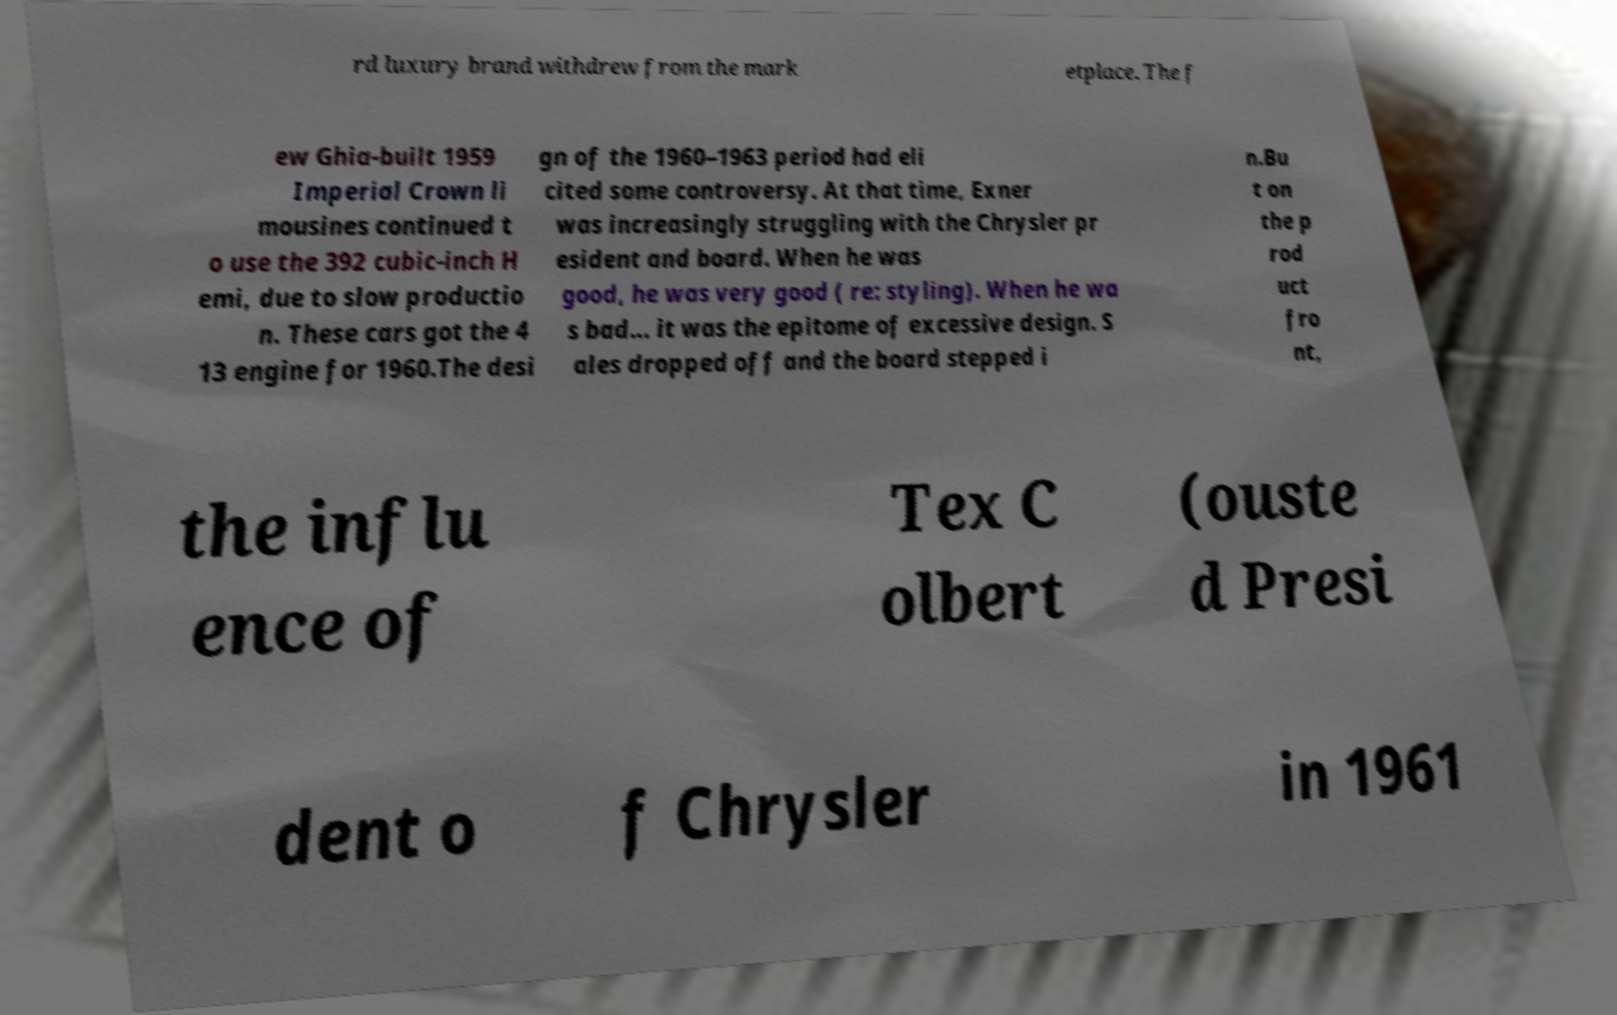Could you assist in decoding the text presented in this image and type it out clearly? rd luxury brand withdrew from the mark etplace. The f ew Ghia-built 1959 Imperial Crown li mousines continued t o use the 392 cubic-inch H emi, due to slow productio n. These cars got the 4 13 engine for 1960.The desi gn of the 1960–1963 period had eli cited some controversy. At that time, Exner was increasingly struggling with the Chrysler pr esident and board. When he was good, he was very good ( re: styling). When he wa s bad... it was the epitome of excessive design. S ales dropped off and the board stepped i n.Bu t on the p rod uct fro nt, the influ ence of Tex C olbert (ouste d Presi dent o f Chrysler in 1961 